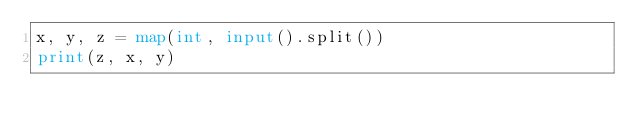<code> <loc_0><loc_0><loc_500><loc_500><_Python_>x, y, z = map(int, input().split())
print(z, x, y)</code> 